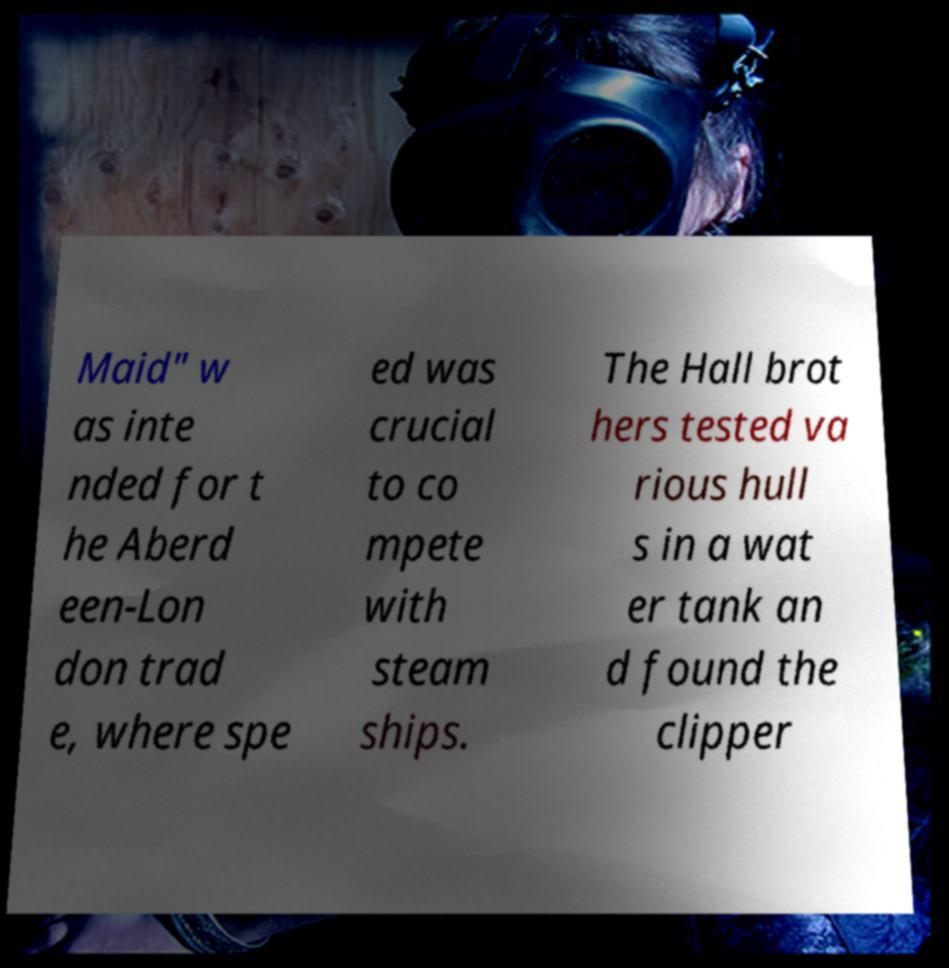Could you extract and type out the text from this image? Maid" w as inte nded for t he Aberd een-Lon don trad e, where spe ed was crucial to co mpete with steam ships. The Hall brot hers tested va rious hull s in a wat er tank an d found the clipper 